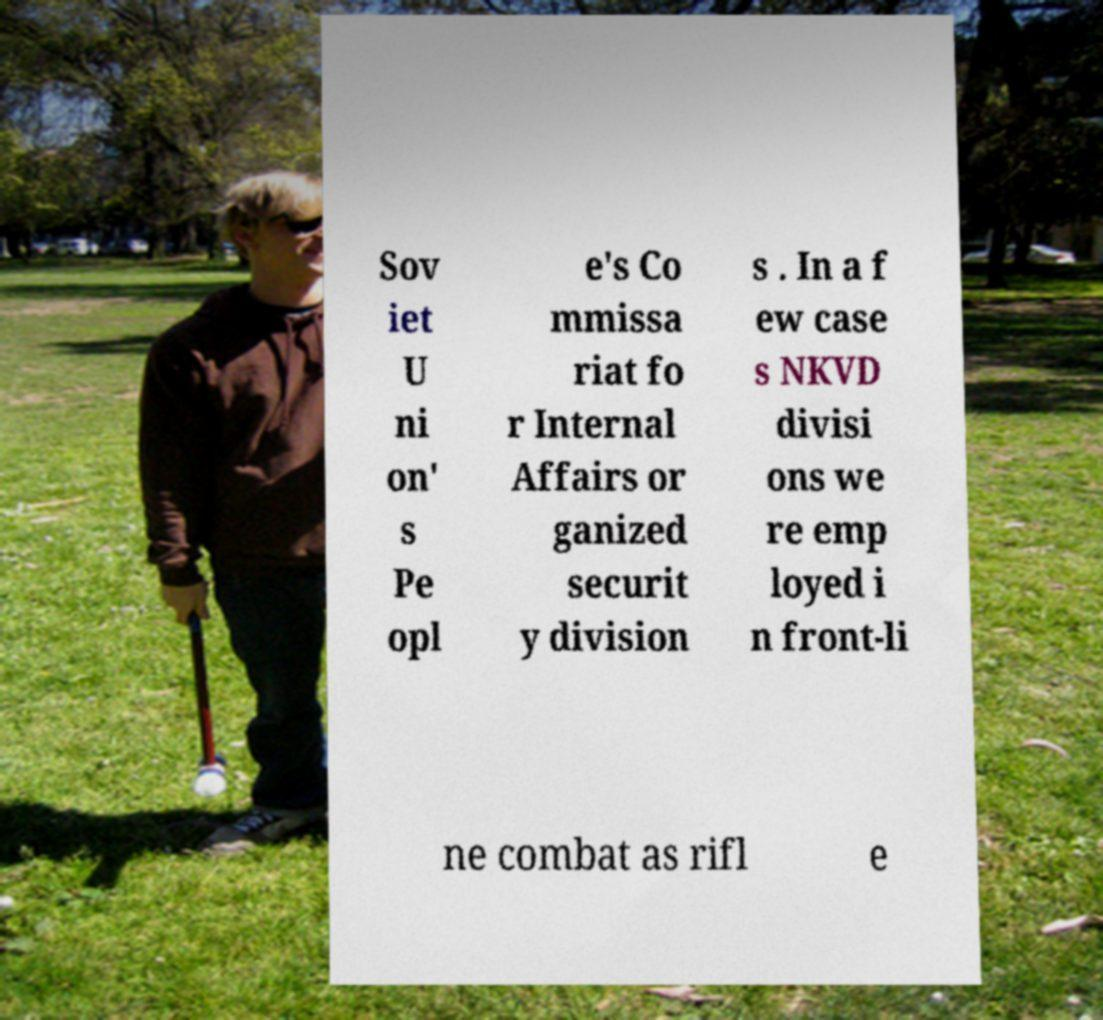I need the written content from this picture converted into text. Can you do that? Sov iet U ni on' s Pe opl e's Co mmissa riat fo r Internal Affairs or ganized securit y division s . In a f ew case s NKVD divisi ons we re emp loyed i n front-li ne combat as rifl e 